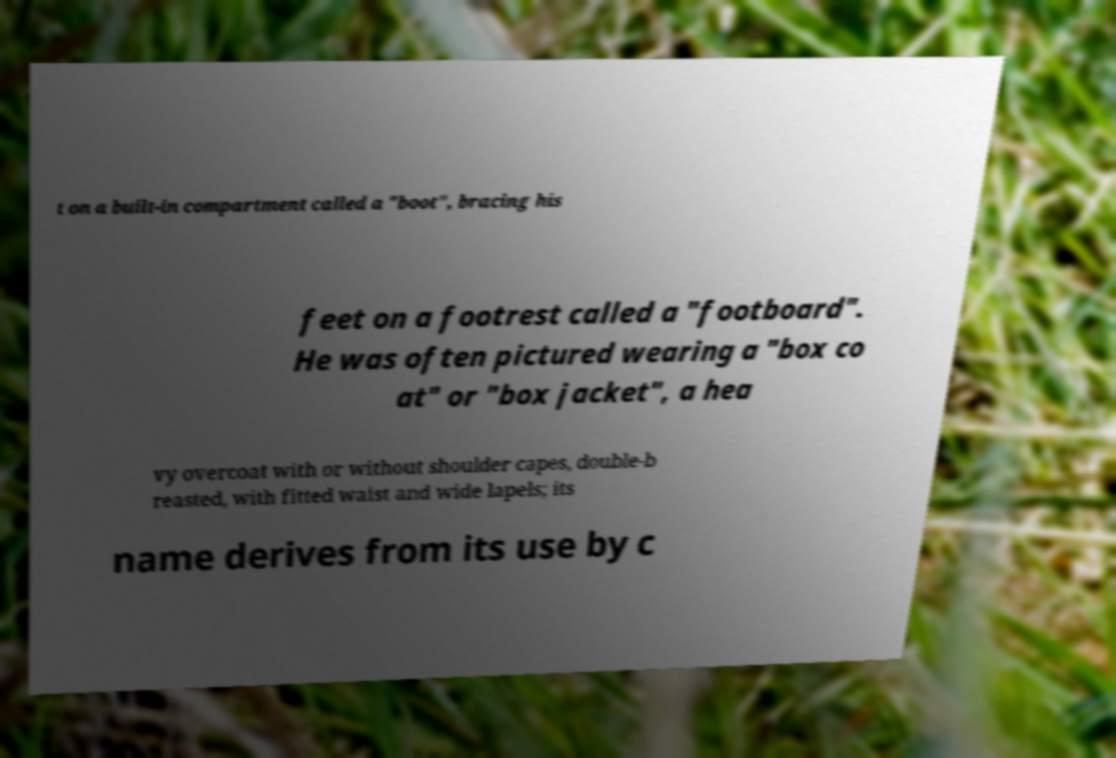I need the written content from this picture converted into text. Can you do that? t on a built-in compartment called a "boot", bracing his feet on a footrest called a "footboard". He was often pictured wearing a "box co at" or "box jacket", a hea vy overcoat with or without shoulder capes, double-b reasted, with fitted waist and wide lapels; its name derives from its use by c 